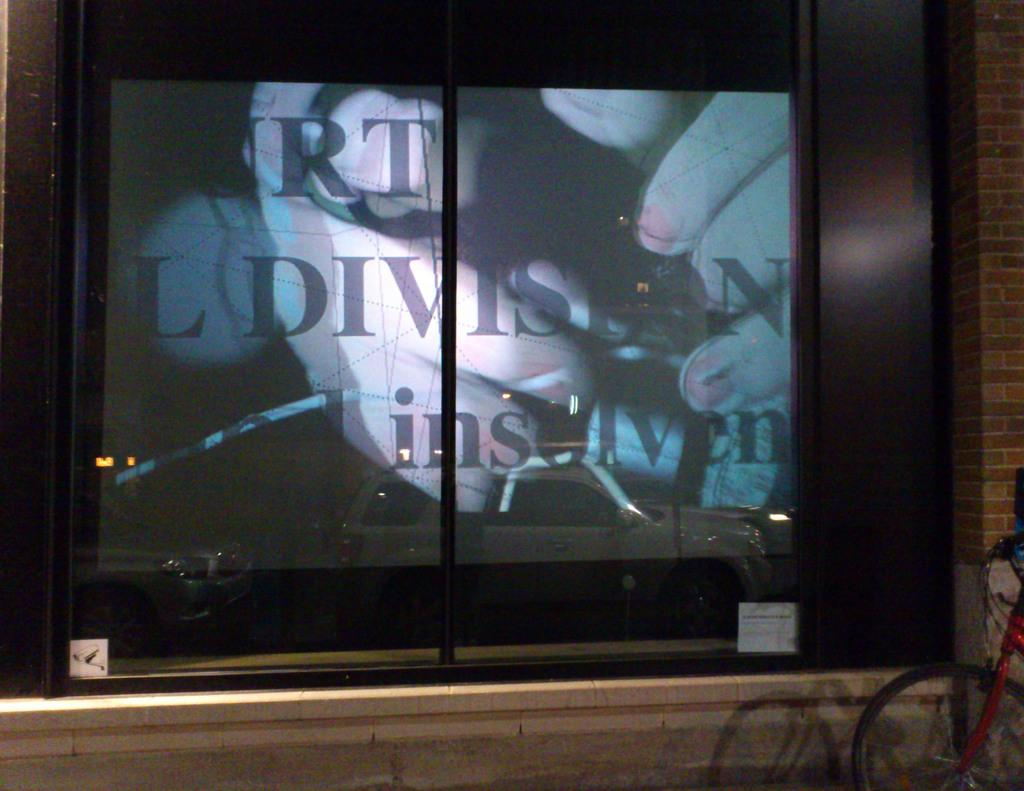<image>
Describe the image concisely. A window display featuring the word division is visible from the sidewalk. 